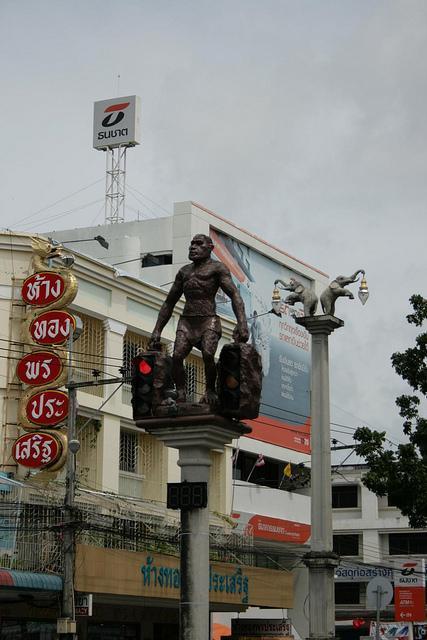How many tracks have a train on them?
Give a very brief answer. 0. 